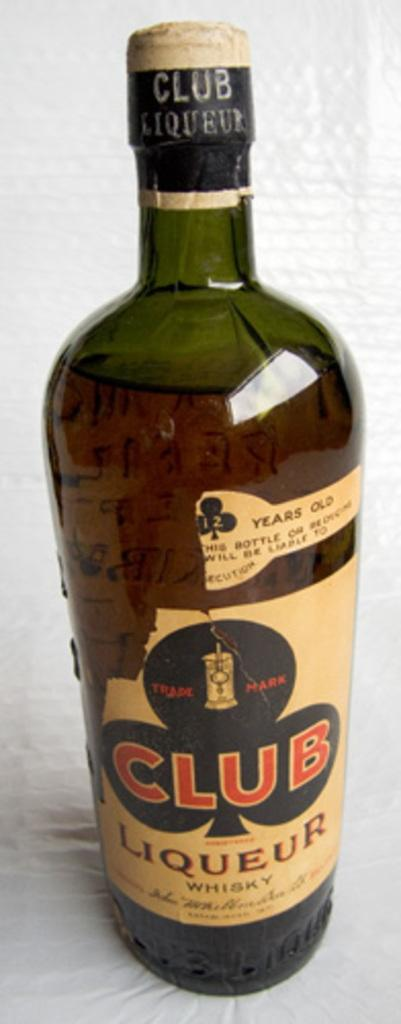<image>
Relay a brief, clear account of the picture shown. A bottle of whiskey that has a tan label and says CLUB Liqueur on the front. 